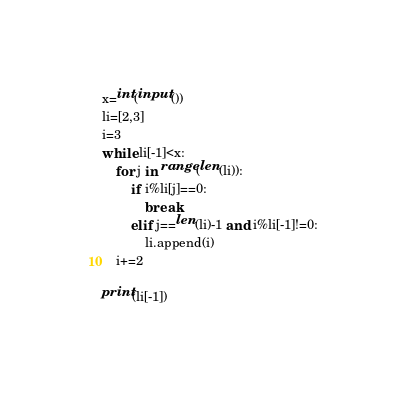<code> <loc_0><loc_0><loc_500><loc_500><_Python_>x=int(input())
li=[2,3]
i=3
while li[-1]<x:
    for j in range(len(li)):
        if i%li[j]==0:
            break
        elif j==len(li)-1 and i%li[-1]!=0:
            li.append(i)    
    i+=2
    
print(li[-1])        
    </code> 